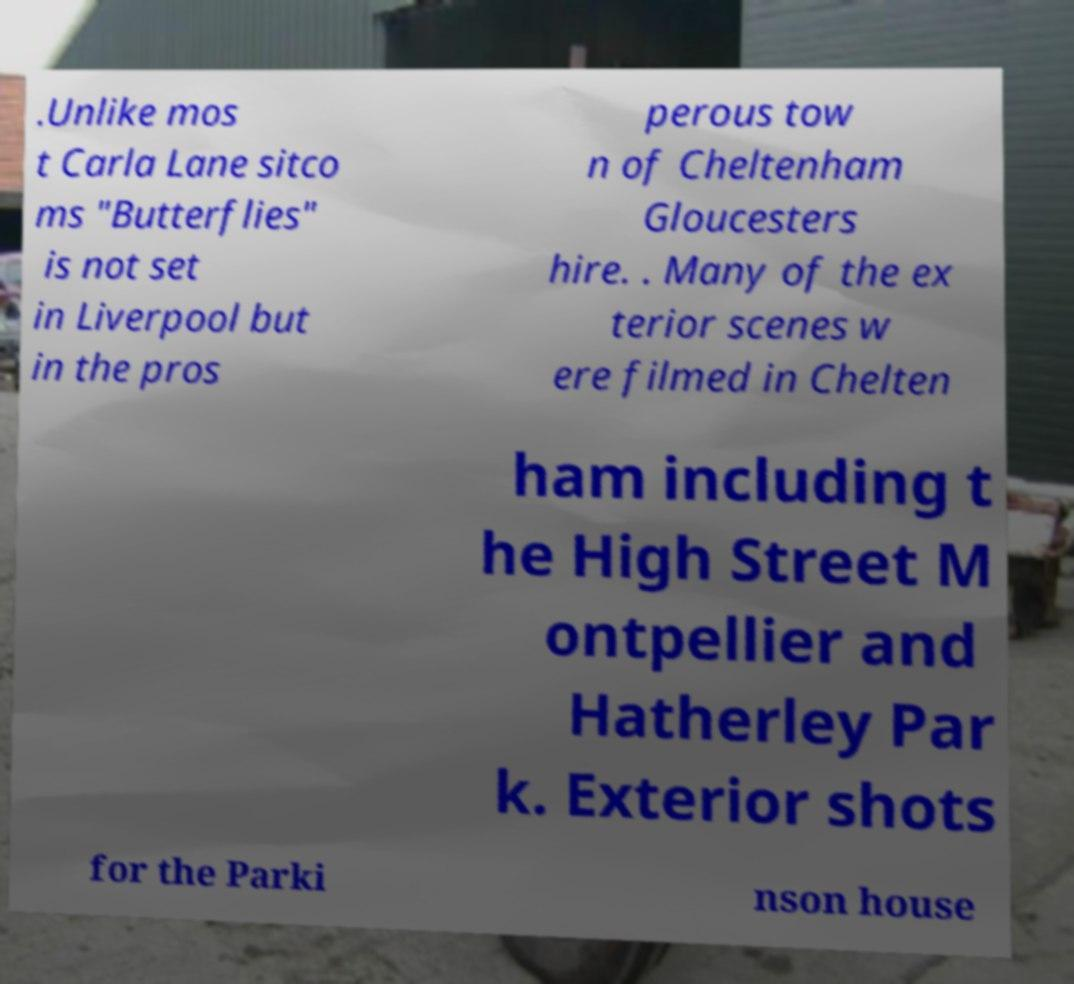Could you assist in decoding the text presented in this image and type it out clearly? .Unlike mos t Carla Lane sitco ms "Butterflies" is not set in Liverpool but in the pros perous tow n of Cheltenham Gloucesters hire. . Many of the ex terior scenes w ere filmed in Chelten ham including t he High Street M ontpellier and Hatherley Par k. Exterior shots for the Parki nson house 